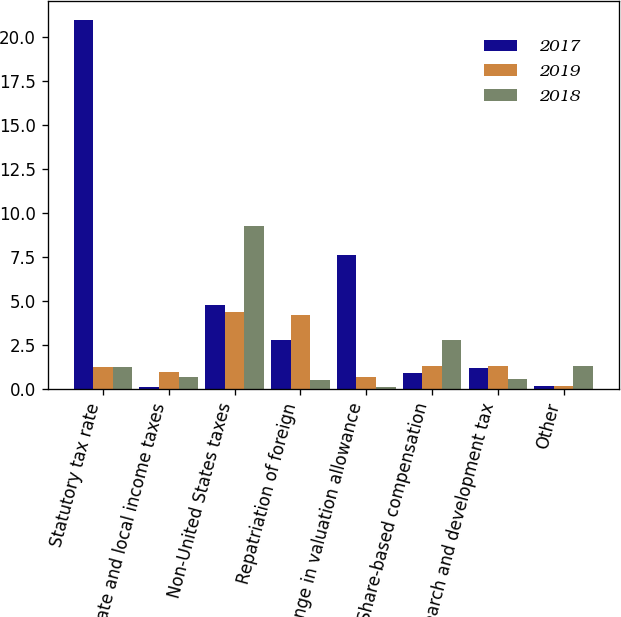Convert chart. <chart><loc_0><loc_0><loc_500><loc_500><stacked_bar_chart><ecel><fcel>Statutory tax rate<fcel>State and local income taxes<fcel>Non-United States taxes<fcel>Repatriation of foreign<fcel>Change in valuation allowance<fcel>Share-based compensation<fcel>Research and development tax<fcel>Other<nl><fcel>2017<fcel>21<fcel>0.1<fcel>4.8<fcel>2.8<fcel>7.6<fcel>0.9<fcel>1.2<fcel>0.2<nl><fcel>2019<fcel>1.25<fcel>1<fcel>4.4<fcel>4.2<fcel>0.7<fcel>1.3<fcel>1.3<fcel>0.2<nl><fcel>2018<fcel>1.25<fcel>0.7<fcel>9.3<fcel>0.5<fcel>0.1<fcel>2.8<fcel>0.6<fcel>1.3<nl></chart> 